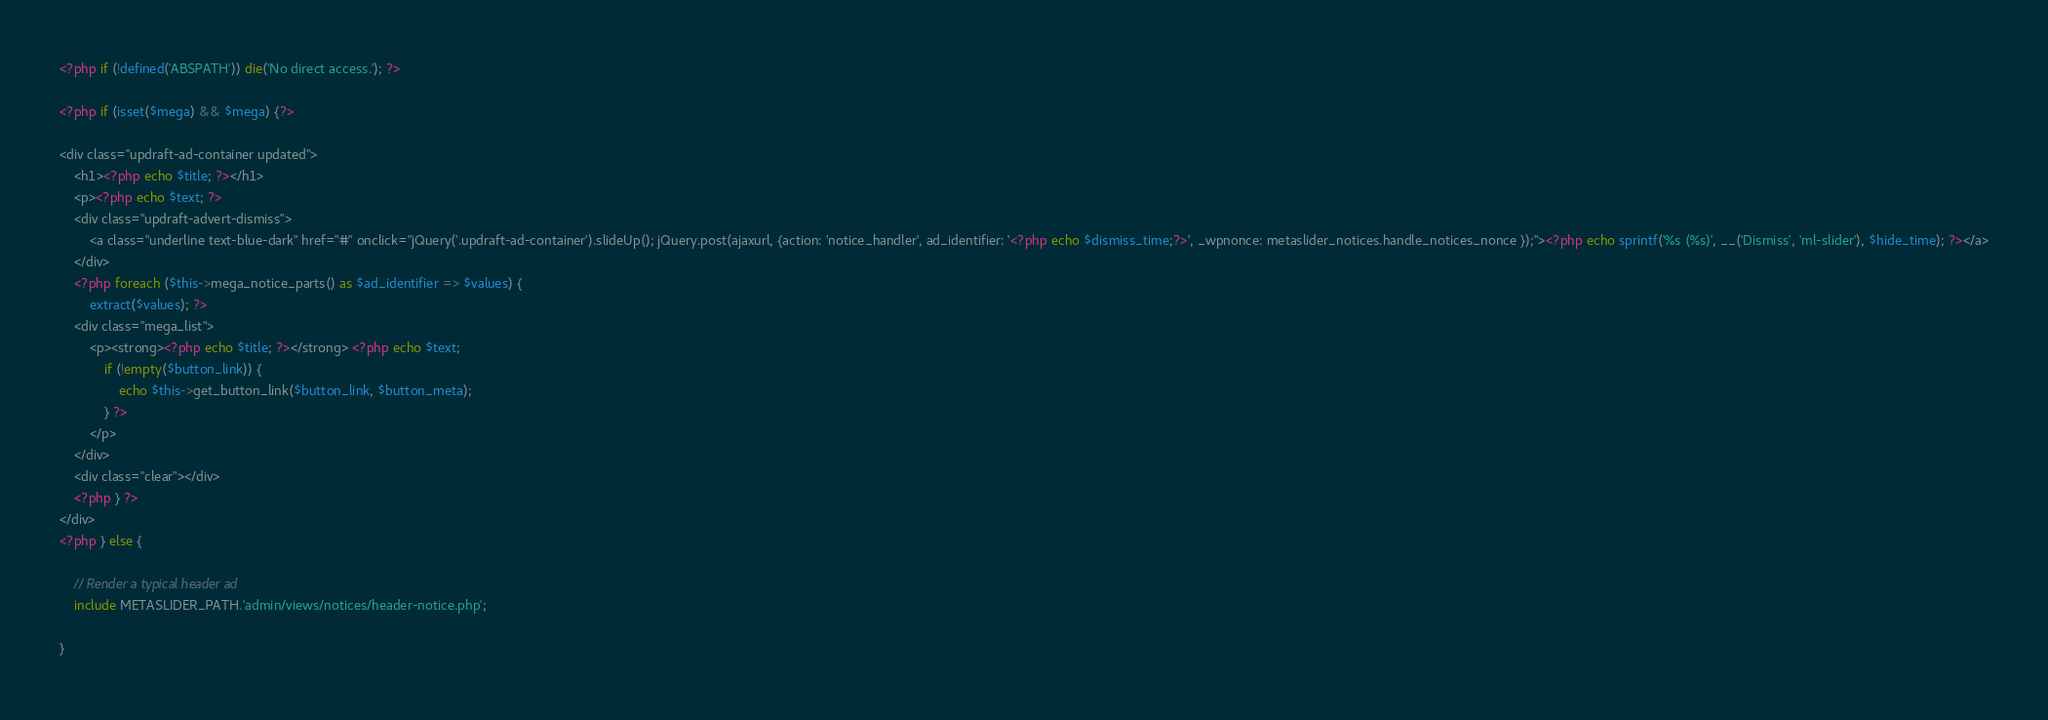<code> <loc_0><loc_0><loc_500><loc_500><_PHP_><?php if (!defined('ABSPATH')) die('No direct access.'); ?>

<?php if (isset($mega) && $mega) {?>

<div class="updraft-ad-container updated">
    <h1><?php echo $title; ?></h1>
    <p><?php echo $text; ?>
    <div class="updraft-advert-dismiss">
        <a class="underline text-blue-dark" href="#" onclick="jQuery('.updraft-ad-container').slideUp(); jQuery.post(ajaxurl, {action: 'notice_handler', ad_identifier: '<?php echo $dismiss_time;?>', _wpnonce: metaslider_notices.handle_notices_nonce });"><?php echo sprintf('%s (%s)', __('Dismiss', 'ml-slider'), $hide_time); ?></a>
    </div>
    <?php foreach ($this->mega_notice_parts() as $ad_identifier => $values) { 
        extract($values); ?>
    <div class="mega_list">
        <p><strong><?php echo $title; ?></strong> <?php echo $text;
            if (!empty($button_link)) {
                echo $this->get_button_link($button_link, $button_meta);
            } ?>
        </p>
    </div>
    <div class="clear"></div>
    <?php } ?>
</div>
<?php } else {
    
    // Render a typical header ad
    include METASLIDER_PATH.'admin/views/notices/header-notice.php';

}
</code> 